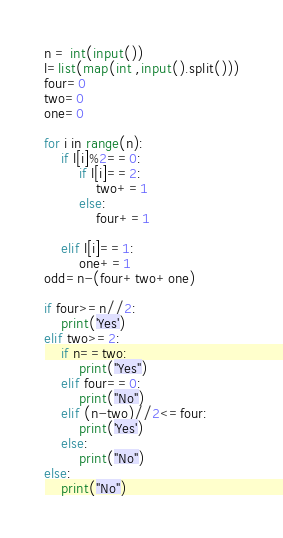Convert code to text. <code><loc_0><loc_0><loc_500><loc_500><_Python_>n = int(input())
l=list(map(int ,input().split()))
four=0
two=0
one=0

for i in range(n):
	if l[i]%2==0:
		if l[i]==2:
			two+=1
		else:
			four+=1

	elif l[i]==1:
		one+=1
odd=n-(four+two+one)

if four>=n//2:
	print('Yes')
elif two>=2:
    if n==two:
        print("Yes")
    elif four==0:
        print("No")
    elif (n-two)//2<=four:
        print('Yes')
    else:
        print("No")
else:
    print("No") </code> 